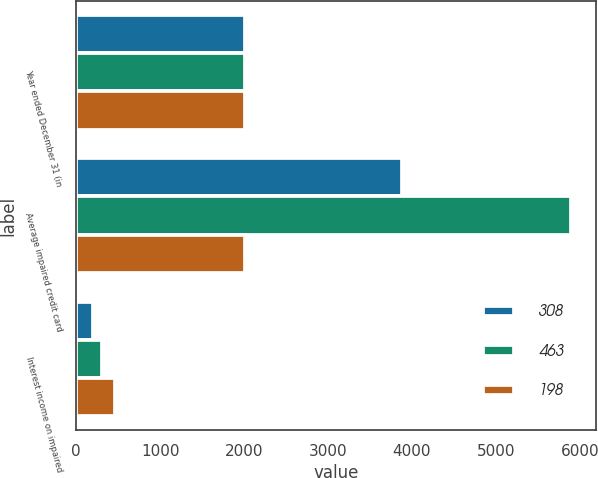Convert chart to OTSL. <chart><loc_0><loc_0><loc_500><loc_500><stacked_bar_chart><ecel><fcel>Year ended December 31 (in<fcel>Average impaired credit card<fcel>Interest income on impaired<nl><fcel>308<fcel>2013<fcel>3882<fcel>198<nl><fcel>463<fcel>2012<fcel>5893<fcel>308<nl><fcel>198<fcel>2011<fcel>2011.5<fcel>463<nl></chart> 